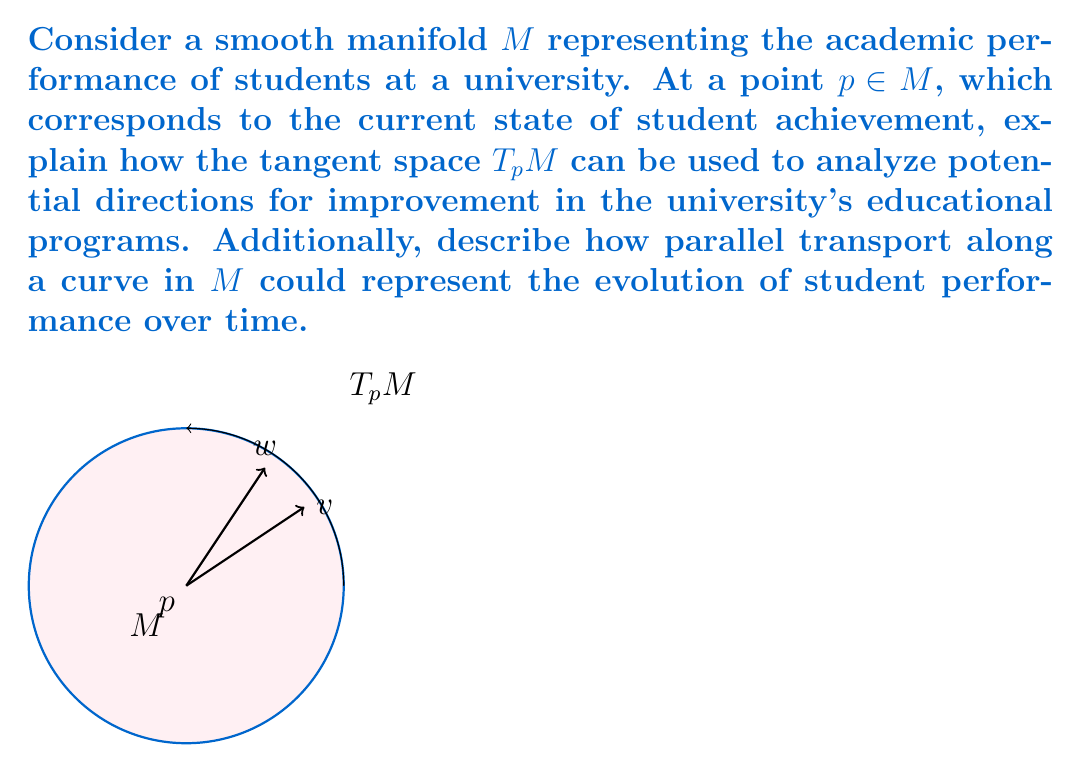Provide a solution to this math problem. To answer this question, let's break it down into steps:

1. Understanding the manifold $M$:
   - $M$ represents the academic performance of students
   - Each point on $M$ corresponds to a particular state of student achievement

2. Tangent space $T_p M$ at point $p$:
   - $T_p M$ is the vector space of all tangent vectors at $p$
   - It represents all possible infinitesimal changes or directions from the current state $p$

3. Analysis of potential improvements:
   - Each vector $v \in T_p M$ represents a possible direction of change in student performance
   - The magnitude of $v$ indicates the rate of change in that direction
   - Different vectors in $T_p M$ can represent various aspects of academic improvement, such as:
     a) Improvement in specific subjects
     b) Enhancement of critical thinking skills
     c) Development of extracurricular abilities

4. Use of tangent space for program analysis:
   - University administrators can use $T_p M$ to:
     a) Identify the most promising directions for improvement
     b) Assess the potential impact of different educational initiatives
     c) Prioritize resources based on the vectors with the highest potential impact

5. Parallel transport along a curve in $M$:
   - A curve $\gamma : [0,1] \to M$ represents the evolution of student performance over time
   - Parallel transport of a vector $v \in T_p M$ along $\gamma$ preserves its length and angle with the curve
   - This can be interpreted as maintaining the consistency of improvement initiatives over time

6. Interpretation of parallel transport:
   - It allows for comparison of improvement strategies at different points in time
   - Ensures that the assessment of educational programs remains consistent as overall performance changes
   - Helps identify if certain improvement directions become more or less effective over time

By using these concepts from differential geometry, university administrators can gain insights into the most effective ways to enhance their educational programs and improve overall student performance.
Answer: Tangent space $T_p M$ represents potential directions for academic improvement, while parallel transport along curves in $M$ models consistent evaluation of improvement strategies over time. 